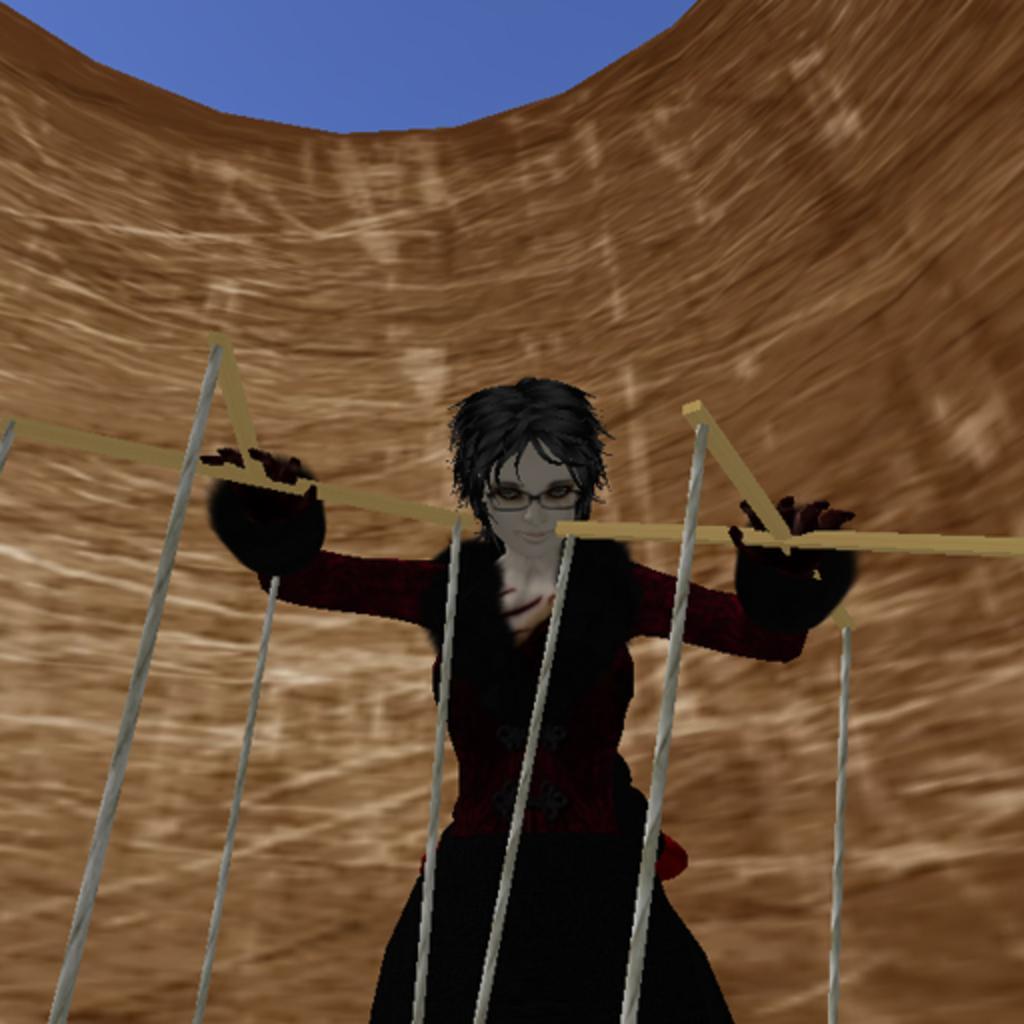Could you give a brief overview of what you see in this image? In this picture I can see there is a woman standing, she is wearing a red shirt and a black skirt. She is holding a wooden sticks and they are some strings attached to it. The sky is clear. 